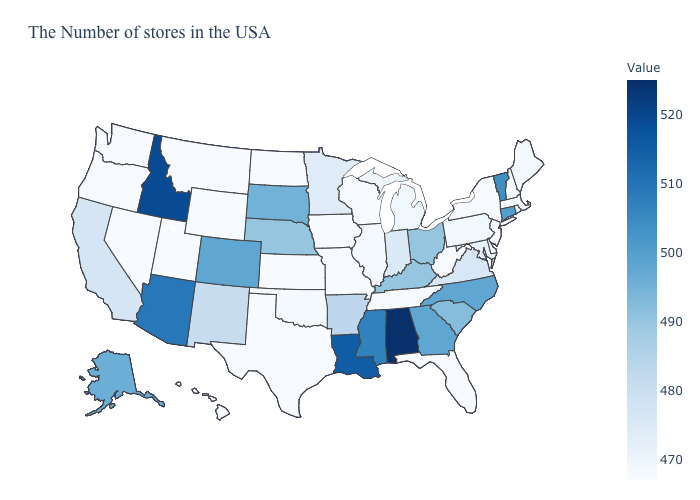Which states hav the highest value in the West?
Write a very short answer. Idaho. Among the states that border Arizona , which have the lowest value?
Concise answer only. Utah, Nevada. Among the states that border Arkansas , which have the highest value?
Concise answer only. Louisiana. Among the states that border Arkansas , which have the lowest value?
Write a very short answer. Tennessee, Missouri, Texas. Which states have the highest value in the USA?
Short answer required. Alabama. 